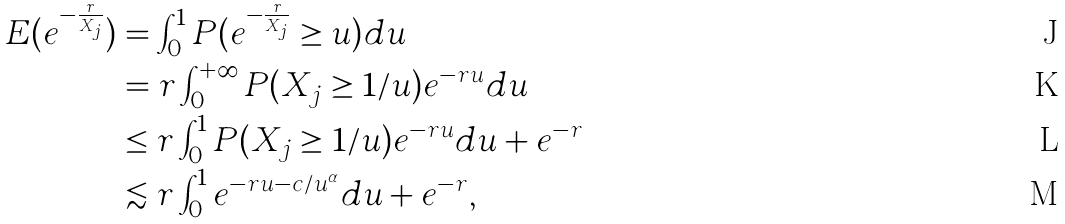<formula> <loc_0><loc_0><loc_500><loc_500>E ( e ^ { - \frac { r } { X _ { j } } } ) & = \int _ { 0 } ^ { 1 } P ( e ^ { - \frac { r } { X _ { j } } } \geq u ) d u \\ & = r \int _ { 0 } ^ { + \infty } P ( X _ { j } \geq 1 / u ) e ^ { - r u } d u \\ & \leq r \int _ { 0 } ^ { 1 } P ( X _ { j } \geq 1 / u ) e ^ { - r u } d u + e ^ { - r } \\ & \lesssim r \int _ { 0 } ^ { 1 } e ^ { - r u - c / u ^ { \alpha } } d u + e ^ { - r } ,</formula> 